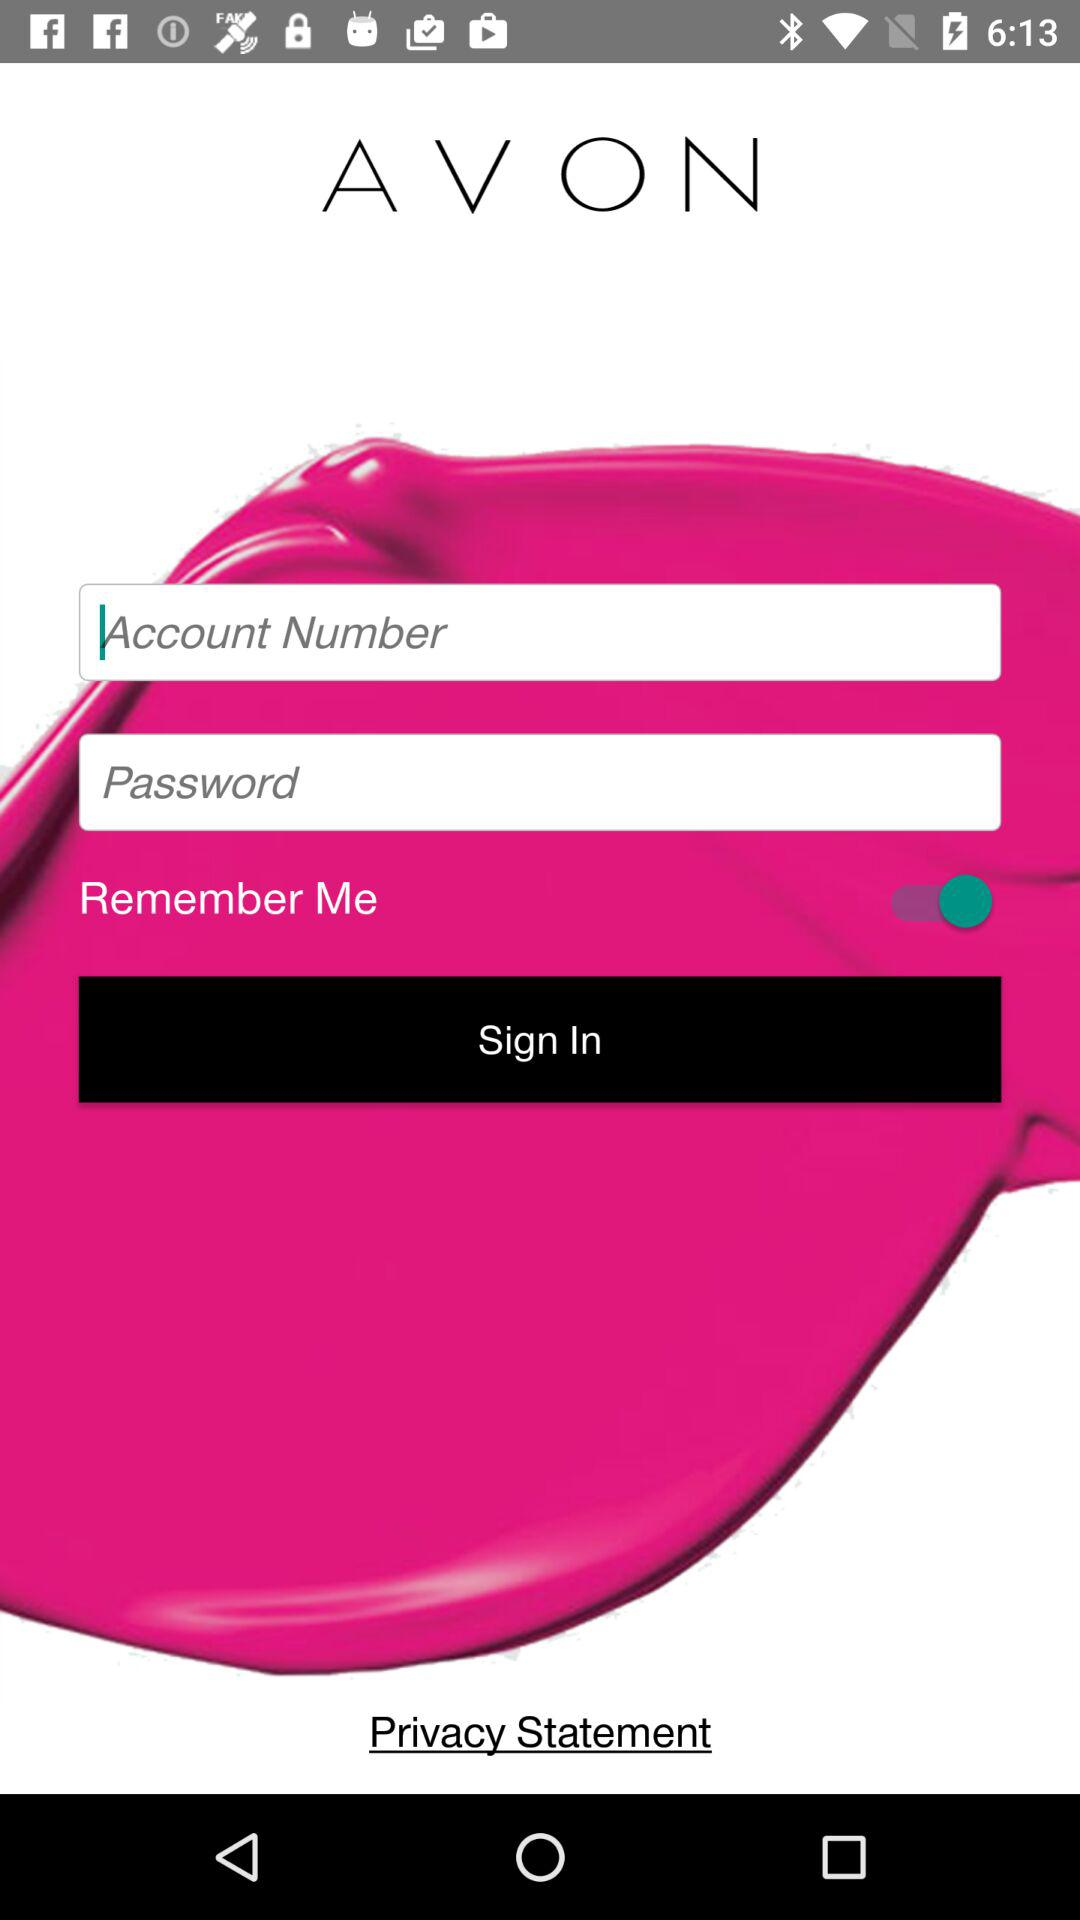What is the entered account number?
When the provided information is insufficient, respond with <no answer>. <no answer> 